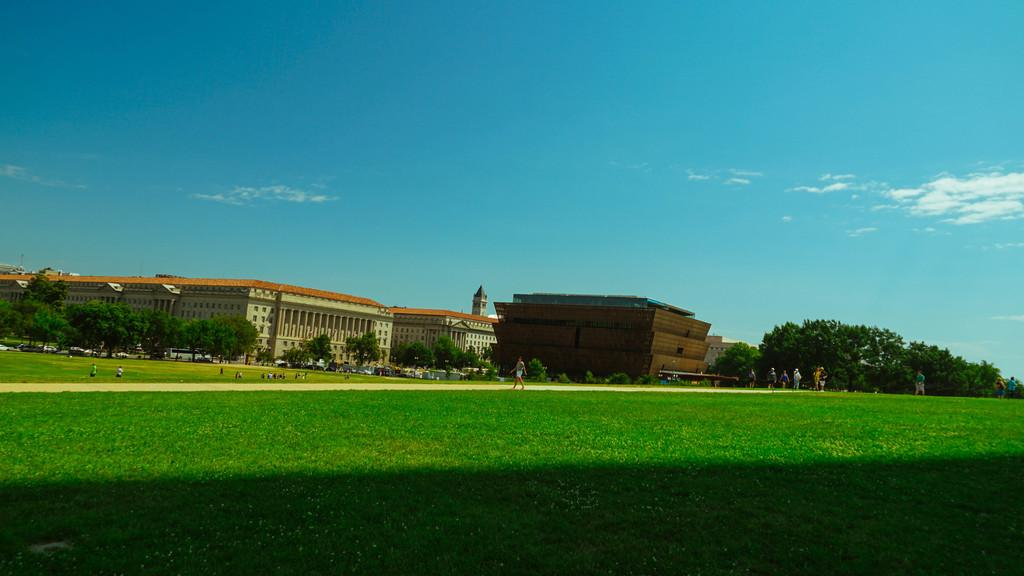What type of terrain is at the bottom of the image? There is a grassy land at the bottom of the image. Who or what can be seen in the image? There are people in the image. What other natural elements are present in the image? There are trees in the image. What man-made structures can be seen in the image? There are buildings in the image. What part of the natural environment is visible in the background of the image? The sky is visible in the background of the image. What color crayon is being used to draw the night sky in the image? There is no crayon or drawing present in the image; it is a photograph or illustration of a scene with a sky visible in the background. 